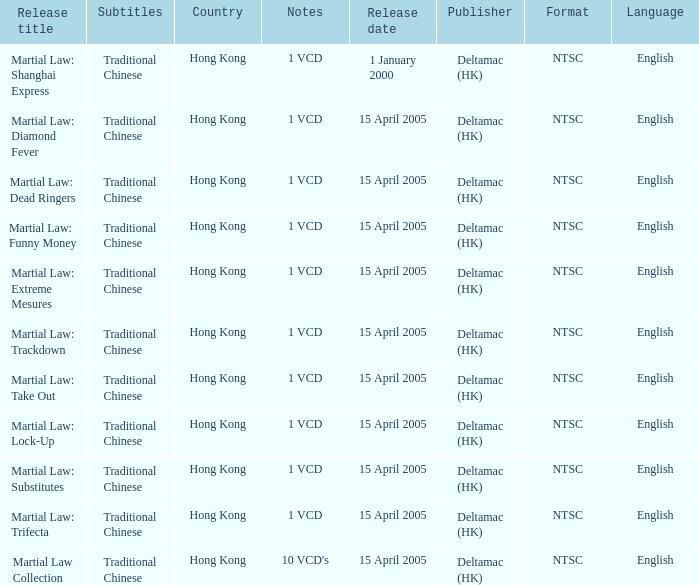Which country had a release of 1 VCD titled Martial Law: Substitutes? Hong Kong. 